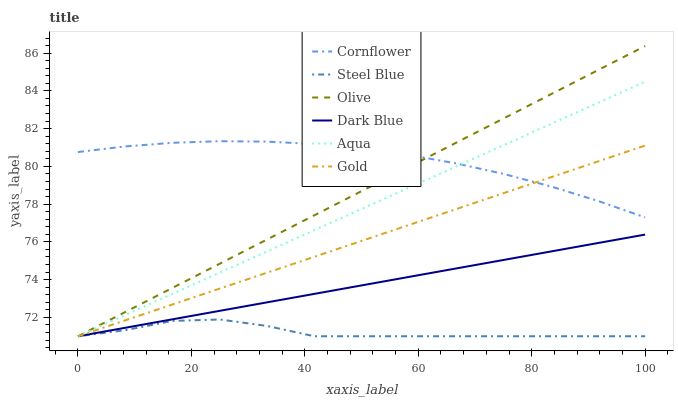Does Gold have the minimum area under the curve?
Answer yes or no. No. Does Gold have the maximum area under the curve?
Answer yes or no. No. Is Gold the smoothest?
Answer yes or no. No. Is Gold the roughest?
Answer yes or no. No. Does Gold have the highest value?
Answer yes or no. No. Is Dark Blue less than Cornflower?
Answer yes or no. Yes. Is Cornflower greater than Steel Blue?
Answer yes or no. Yes. Does Dark Blue intersect Cornflower?
Answer yes or no. No. 